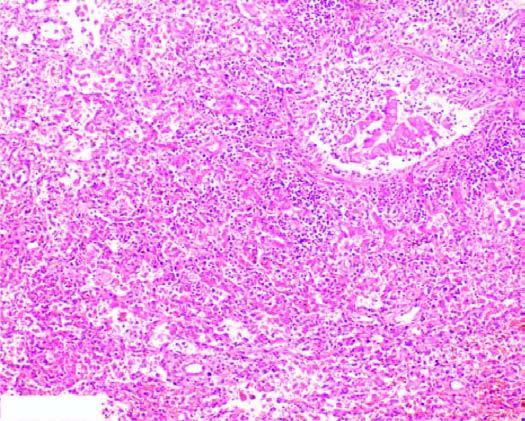why are the alveolar septa thickened?
Answer the question using a single word or phrase. Due to congested capillaries and neutrophilic infiltrate 